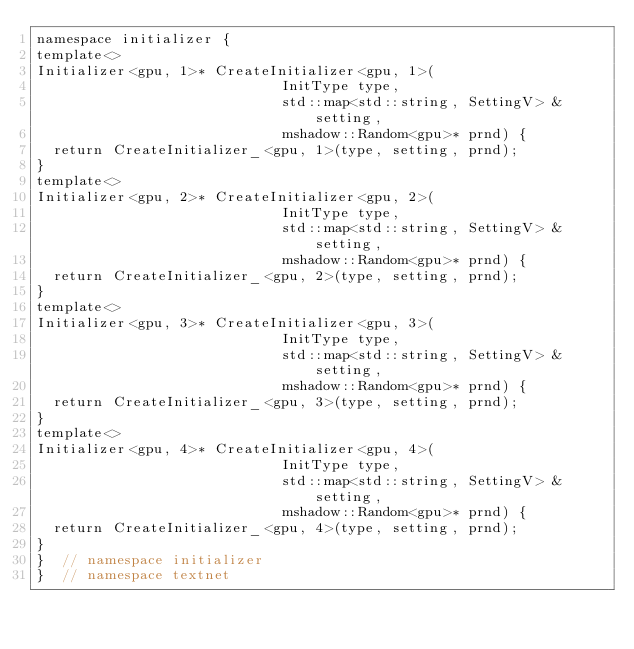<code> <loc_0><loc_0><loc_500><loc_500><_Cuda_>namespace initializer {
template<>
Initializer<gpu, 1>* CreateInitializer<gpu, 1>(
                             InitType type,
                             std::map<std::string, SettingV> &setting,
                             mshadow::Random<gpu>* prnd) {
  return CreateInitializer_<gpu, 1>(type, setting, prnd); 
}
template<>
Initializer<gpu, 2>* CreateInitializer<gpu, 2>(
                             InitType type,
                             std::map<std::string, SettingV> &setting,
                             mshadow::Random<gpu>* prnd) {
  return CreateInitializer_<gpu, 2>(type, setting, prnd); 
}
template<>
Initializer<gpu, 3>* CreateInitializer<gpu, 3>(
                             InitType type,
                             std::map<std::string, SettingV> &setting,
                             mshadow::Random<gpu>* prnd) {
  return CreateInitializer_<gpu, 3>(type, setting, prnd); 
}
template<>
Initializer<gpu, 4>* CreateInitializer<gpu, 4>(
                             InitType type,
                             std::map<std::string, SettingV> &setting,
                             mshadow::Random<gpu>* prnd) {
  return CreateInitializer_<gpu, 4>(type, setting, prnd); 
}
}  // namespace initializer
}  // namespace textnet
</code> 